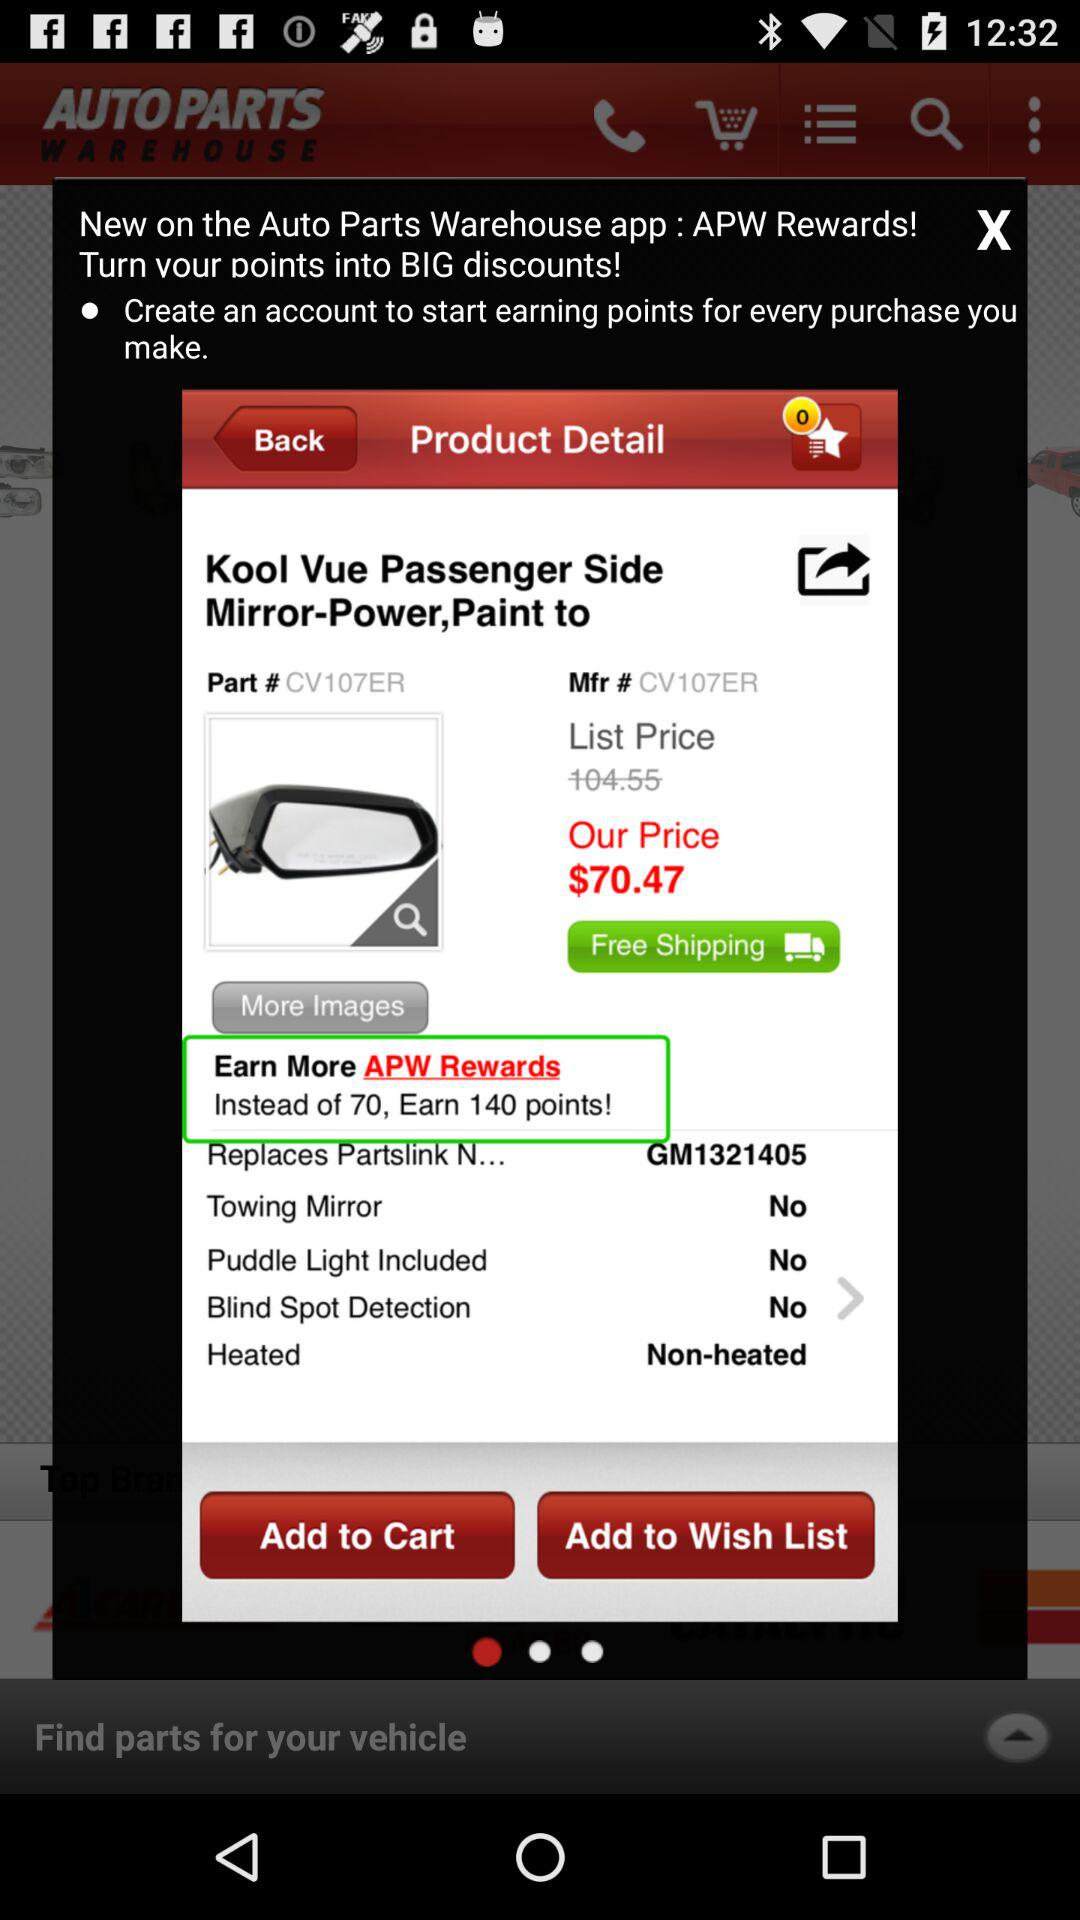What is the cost of shipping?
Answer the question using a single word or phrase. Shipping is free. 